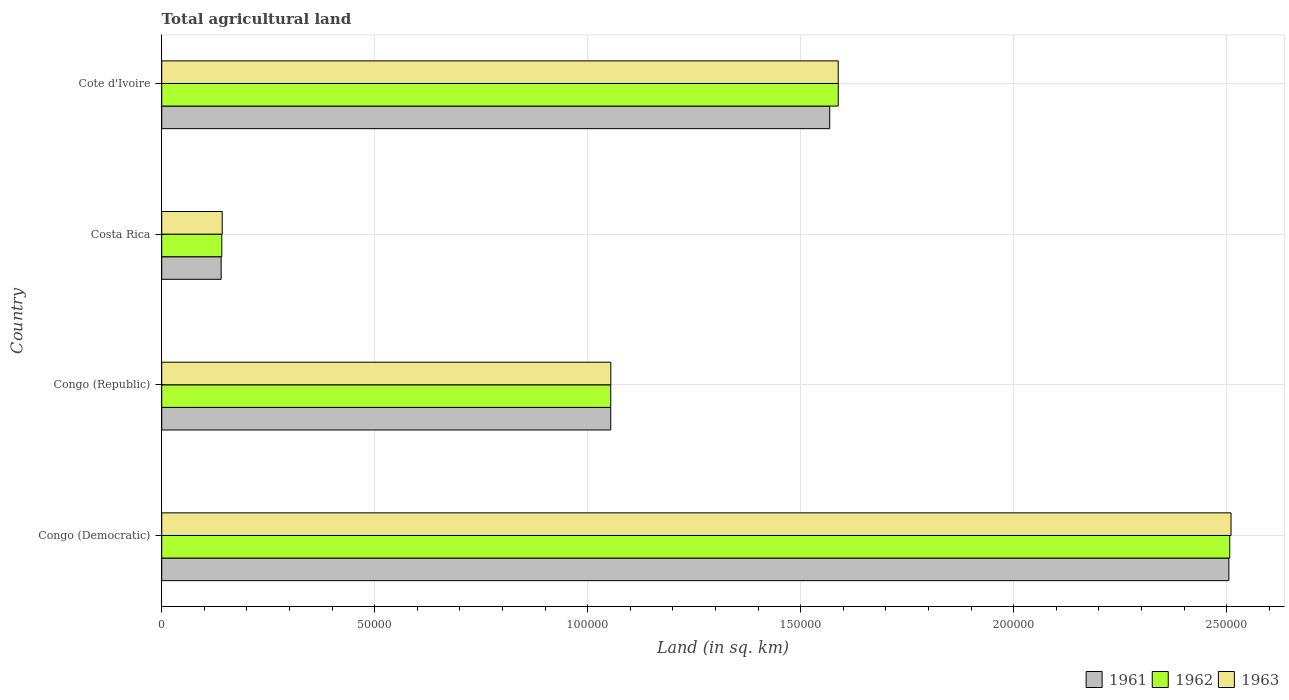How many different coloured bars are there?
Keep it short and to the point. 3. How many bars are there on the 4th tick from the bottom?
Make the answer very short. 3. What is the label of the 3rd group of bars from the top?
Give a very brief answer. Congo (Republic). What is the total agricultural land in 1961 in Cote d'Ivoire?
Provide a short and direct response. 1.57e+05. Across all countries, what is the maximum total agricultural land in 1963?
Keep it short and to the point. 2.51e+05. Across all countries, what is the minimum total agricultural land in 1963?
Keep it short and to the point. 1.42e+04. In which country was the total agricultural land in 1962 maximum?
Give a very brief answer. Congo (Democratic). What is the total total agricultural land in 1963 in the graph?
Provide a short and direct response. 5.29e+05. What is the difference between the total agricultural land in 1961 in Congo (Republic) and that in Costa Rica?
Make the answer very short. 9.14e+04. What is the difference between the total agricultural land in 1963 in Congo (Republic) and the total agricultural land in 1961 in Congo (Democratic)?
Make the answer very short. -1.45e+05. What is the average total agricultural land in 1963 per country?
Give a very brief answer. 1.32e+05. What is the difference between the total agricultural land in 1961 and total agricultural land in 1963 in Congo (Democratic)?
Give a very brief answer. -500. In how many countries, is the total agricultural land in 1962 greater than 10000 sq.km?
Offer a very short reply. 4. What is the ratio of the total agricultural land in 1962 in Congo (Democratic) to that in Cote d'Ivoire?
Offer a terse response. 1.58. Is the total agricultural land in 1961 in Costa Rica less than that in Cote d'Ivoire?
Make the answer very short. Yes. What is the difference between the highest and the second highest total agricultural land in 1961?
Provide a short and direct response. 9.37e+04. What is the difference between the highest and the lowest total agricultural land in 1961?
Give a very brief answer. 2.37e+05. In how many countries, is the total agricultural land in 1961 greater than the average total agricultural land in 1961 taken over all countries?
Keep it short and to the point. 2. What does the 1st bar from the bottom in Congo (Democratic) represents?
Ensure brevity in your answer.  1961. How many countries are there in the graph?
Your response must be concise. 4. What is the difference between two consecutive major ticks on the X-axis?
Keep it short and to the point. 5.00e+04. Are the values on the major ticks of X-axis written in scientific E-notation?
Your response must be concise. No. Does the graph contain any zero values?
Give a very brief answer. No. Does the graph contain grids?
Give a very brief answer. Yes. Where does the legend appear in the graph?
Provide a succinct answer. Bottom right. How many legend labels are there?
Provide a succinct answer. 3. What is the title of the graph?
Offer a very short reply. Total agricultural land. What is the label or title of the X-axis?
Your response must be concise. Land (in sq. km). What is the Land (in sq. km) of 1961 in Congo (Democratic)?
Ensure brevity in your answer.  2.50e+05. What is the Land (in sq. km) in 1962 in Congo (Democratic)?
Give a very brief answer. 2.51e+05. What is the Land (in sq. km) in 1963 in Congo (Democratic)?
Keep it short and to the point. 2.51e+05. What is the Land (in sq. km) in 1961 in Congo (Republic)?
Your answer should be compact. 1.05e+05. What is the Land (in sq. km) of 1962 in Congo (Republic)?
Ensure brevity in your answer.  1.05e+05. What is the Land (in sq. km) of 1963 in Congo (Republic)?
Give a very brief answer. 1.05e+05. What is the Land (in sq. km) of 1961 in Costa Rica?
Offer a very short reply. 1.40e+04. What is the Land (in sq. km) in 1962 in Costa Rica?
Make the answer very short. 1.41e+04. What is the Land (in sq. km) of 1963 in Costa Rica?
Offer a terse response. 1.42e+04. What is the Land (in sq. km) of 1961 in Cote d'Ivoire?
Offer a terse response. 1.57e+05. What is the Land (in sq. km) in 1962 in Cote d'Ivoire?
Ensure brevity in your answer.  1.59e+05. What is the Land (in sq. km) in 1963 in Cote d'Ivoire?
Make the answer very short. 1.59e+05. Across all countries, what is the maximum Land (in sq. km) in 1961?
Your answer should be very brief. 2.50e+05. Across all countries, what is the maximum Land (in sq. km) in 1962?
Provide a short and direct response. 2.51e+05. Across all countries, what is the maximum Land (in sq. km) of 1963?
Provide a short and direct response. 2.51e+05. Across all countries, what is the minimum Land (in sq. km) in 1961?
Give a very brief answer. 1.40e+04. Across all countries, what is the minimum Land (in sq. km) of 1962?
Your answer should be very brief. 1.41e+04. Across all countries, what is the minimum Land (in sq. km) in 1963?
Provide a short and direct response. 1.42e+04. What is the total Land (in sq. km) of 1961 in the graph?
Offer a very short reply. 5.27e+05. What is the total Land (in sq. km) of 1962 in the graph?
Make the answer very short. 5.29e+05. What is the total Land (in sq. km) in 1963 in the graph?
Your answer should be very brief. 5.29e+05. What is the difference between the Land (in sq. km) in 1961 in Congo (Democratic) and that in Congo (Republic)?
Keep it short and to the point. 1.45e+05. What is the difference between the Land (in sq. km) in 1962 in Congo (Democratic) and that in Congo (Republic)?
Your answer should be compact. 1.45e+05. What is the difference between the Land (in sq. km) in 1963 in Congo (Democratic) and that in Congo (Republic)?
Keep it short and to the point. 1.46e+05. What is the difference between the Land (in sq. km) in 1961 in Congo (Democratic) and that in Costa Rica?
Make the answer very short. 2.37e+05. What is the difference between the Land (in sq. km) in 1962 in Congo (Democratic) and that in Costa Rica?
Offer a terse response. 2.37e+05. What is the difference between the Land (in sq. km) in 1963 in Congo (Democratic) and that in Costa Rica?
Make the answer very short. 2.37e+05. What is the difference between the Land (in sq. km) of 1961 in Congo (Democratic) and that in Cote d'Ivoire?
Keep it short and to the point. 9.37e+04. What is the difference between the Land (in sq. km) in 1962 in Congo (Democratic) and that in Cote d'Ivoire?
Offer a terse response. 9.19e+04. What is the difference between the Land (in sq. km) in 1963 in Congo (Democratic) and that in Cote d'Ivoire?
Make the answer very short. 9.22e+04. What is the difference between the Land (in sq. km) of 1961 in Congo (Republic) and that in Costa Rica?
Your answer should be very brief. 9.14e+04. What is the difference between the Land (in sq. km) in 1962 in Congo (Republic) and that in Costa Rica?
Offer a terse response. 9.13e+04. What is the difference between the Land (in sq. km) in 1963 in Congo (Republic) and that in Costa Rica?
Ensure brevity in your answer.  9.12e+04. What is the difference between the Land (in sq. km) in 1961 in Congo (Republic) and that in Cote d'Ivoire?
Ensure brevity in your answer.  -5.14e+04. What is the difference between the Land (in sq. km) of 1962 in Congo (Republic) and that in Cote d'Ivoire?
Your answer should be very brief. -5.34e+04. What is the difference between the Land (in sq. km) in 1963 in Congo (Republic) and that in Cote d'Ivoire?
Provide a succinct answer. -5.34e+04. What is the difference between the Land (in sq. km) of 1961 in Costa Rica and that in Cote d'Ivoire?
Offer a very short reply. -1.43e+05. What is the difference between the Land (in sq. km) in 1962 in Costa Rica and that in Cote d'Ivoire?
Provide a succinct answer. -1.45e+05. What is the difference between the Land (in sq. km) of 1963 in Costa Rica and that in Cote d'Ivoire?
Keep it short and to the point. -1.45e+05. What is the difference between the Land (in sq. km) of 1961 in Congo (Democratic) and the Land (in sq. km) of 1962 in Congo (Republic)?
Keep it short and to the point. 1.45e+05. What is the difference between the Land (in sq. km) of 1961 in Congo (Democratic) and the Land (in sq. km) of 1963 in Congo (Republic)?
Your response must be concise. 1.45e+05. What is the difference between the Land (in sq. km) in 1962 in Congo (Democratic) and the Land (in sq. km) in 1963 in Congo (Republic)?
Make the answer very short. 1.45e+05. What is the difference between the Land (in sq. km) in 1961 in Congo (Democratic) and the Land (in sq. km) in 1962 in Costa Rica?
Keep it short and to the point. 2.36e+05. What is the difference between the Land (in sq. km) in 1961 in Congo (Democratic) and the Land (in sq. km) in 1963 in Costa Rica?
Make the answer very short. 2.36e+05. What is the difference between the Land (in sq. km) of 1962 in Congo (Democratic) and the Land (in sq. km) of 1963 in Costa Rica?
Your answer should be very brief. 2.36e+05. What is the difference between the Land (in sq. km) of 1961 in Congo (Democratic) and the Land (in sq. km) of 1962 in Cote d'Ivoire?
Provide a short and direct response. 9.17e+04. What is the difference between the Land (in sq. km) in 1961 in Congo (Democratic) and the Land (in sq. km) in 1963 in Cote d'Ivoire?
Give a very brief answer. 9.17e+04. What is the difference between the Land (in sq. km) of 1962 in Congo (Democratic) and the Land (in sq. km) of 1963 in Cote d'Ivoire?
Make the answer very short. 9.19e+04. What is the difference between the Land (in sq. km) of 1961 in Congo (Republic) and the Land (in sq. km) of 1962 in Costa Rica?
Keep it short and to the point. 9.13e+04. What is the difference between the Land (in sq. km) in 1961 in Congo (Republic) and the Land (in sq. km) in 1963 in Costa Rica?
Your response must be concise. 9.12e+04. What is the difference between the Land (in sq. km) of 1962 in Congo (Republic) and the Land (in sq. km) of 1963 in Costa Rica?
Keep it short and to the point. 9.12e+04. What is the difference between the Land (in sq. km) in 1961 in Congo (Republic) and the Land (in sq. km) in 1962 in Cote d'Ivoire?
Your answer should be compact. -5.34e+04. What is the difference between the Land (in sq. km) in 1961 in Congo (Republic) and the Land (in sq. km) in 1963 in Cote d'Ivoire?
Keep it short and to the point. -5.34e+04. What is the difference between the Land (in sq. km) of 1962 in Congo (Republic) and the Land (in sq. km) of 1963 in Cote d'Ivoire?
Provide a short and direct response. -5.34e+04. What is the difference between the Land (in sq. km) of 1961 in Costa Rica and the Land (in sq. km) of 1962 in Cote d'Ivoire?
Provide a short and direct response. -1.45e+05. What is the difference between the Land (in sq. km) of 1961 in Costa Rica and the Land (in sq. km) of 1963 in Cote d'Ivoire?
Provide a short and direct response. -1.45e+05. What is the difference between the Land (in sq. km) of 1962 in Costa Rica and the Land (in sq. km) of 1963 in Cote d'Ivoire?
Your response must be concise. -1.45e+05. What is the average Land (in sq. km) of 1961 per country?
Make the answer very short. 1.32e+05. What is the average Land (in sq. km) of 1962 per country?
Your answer should be very brief. 1.32e+05. What is the average Land (in sq. km) of 1963 per country?
Offer a terse response. 1.32e+05. What is the difference between the Land (in sq. km) in 1961 and Land (in sq. km) in 1962 in Congo (Democratic)?
Ensure brevity in your answer.  -200. What is the difference between the Land (in sq. km) of 1961 and Land (in sq. km) of 1963 in Congo (Democratic)?
Make the answer very short. -500. What is the difference between the Land (in sq. km) of 1962 and Land (in sq. km) of 1963 in Congo (Democratic)?
Make the answer very short. -300. What is the difference between the Land (in sq. km) of 1961 and Land (in sq. km) of 1962 in Congo (Republic)?
Give a very brief answer. 0. What is the difference between the Land (in sq. km) in 1961 and Land (in sq. km) in 1962 in Costa Rica?
Give a very brief answer. -150. What is the difference between the Land (in sq. km) in 1961 and Land (in sq. km) in 1963 in Costa Rica?
Your response must be concise. -250. What is the difference between the Land (in sq. km) of 1962 and Land (in sq. km) of 1963 in Costa Rica?
Give a very brief answer. -100. What is the difference between the Land (in sq. km) of 1961 and Land (in sq. km) of 1962 in Cote d'Ivoire?
Your answer should be compact. -2000. What is the difference between the Land (in sq. km) of 1961 and Land (in sq. km) of 1963 in Cote d'Ivoire?
Make the answer very short. -2000. What is the difference between the Land (in sq. km) of 1962 and Land (in sq. km) of 1963 in Cote d'Ivoire?
Ensure brevity in your answer.  0. What is the ratio of the Land (in sq. km) of 1961 in Congo (Democratic) to that in Congo (Republic)?
Your answer should be compact. 2.38. What is the ratio of the Land (in sq. km) of 1962 in Congo (Democratic) to that in Congo (Republic)?
Provide a short and direct response. 2.38. What is the ratio of the Land (in sq. km) of 1963 in Congo (Democratic) to that in Congo (Republic)?
Ensure brevity in your answer.  2.38. What is the ratio of the Land (in sq. km) of 1961 in Congo (Democratic) to that in Costa Rica?
Your response must be concise. 17.96. What is the ratio of the Land (in sq. km) of 1962 in Congo (Democratic) to that in Costa Rica?
Make the answer very short. 17.78. What is the ratio of the Land (in sq. km) in 1963 in Congo (Democratic) to that in Costa Rica?
Keep it short and to the point. 17.68. What is the ratio of the Land (in sq. km) in 1961 in Congo (Democratic) to that in Cote d'Ivoire?
Ensure brevity in your answer.  1.6. What is the ratio of the Land (in sq. km) of 1962 in Congo (Democratic) to that in Cote d'Ivoire?
Offer a very short reply. 1.58. What is the ratio of the Land (in sq. km) of 1963 in Congo (Democratic) to that in Cote d'Ivoire?
Provide a succinct answer. 1.58. What is the ratio of the Land (in sq. km) in 1961 in Congo (Republic) to that in Costa Rica?
Provide a succinct answer. 7.56. What is the ratio of the Land (in sq. km) in 1962 in Congo (Republic) to that in Costa Rica?
Give a very brief answer. 7.48. What is the ratio of the Land (in sq. km) in 1963 in Congo (Republic) to that in Costa Rica?
Give a very brief answer. 7.42. What is the ratio of the Land (in sq. km) of 1961 in Congo (Republic) to that in Cote d'Ivoire?
Offer a very short reply. 0.67. What is the ratio of the Land (in sq. km) of 1962 in Congo (Republic) to that in Cote d'Ivoire?
Provide a succinct answer. 0.66. What is the ratio of the Land (in sq. km) of 1963 in Congo (Republic) to that in Cote d'Ivoire?
Keep it short and to the point. 0.66. What is the ratio of the Land (in sq. km) of 1961 in Costa Rica to that in Cote d'Ivoire?
Your response must be concise. 0.09. What is the ratio of the Land (in sq. km) in 1962 in Costa Rica to that in Cote d'Ivoire?
Offer a very short reply. 0.09. What is the ratio of the Land (in sq. km) of 1963 in Costa Rica to that in Cote d'Ivoire?
Offer a very short reply. 0.09. What is the difference between the highest and the second highest Land (in sq. km) in 1961?
Provide a short and direct response. 9.37e+04. What is the difference between the highest and the second highest Land (in sq. km) in 1962?
Keep it short and to the point. 9.19e+04. What is the difference between the highest and the second highest Land (in sq. km) of 1963?
Make the answer very short. 9.22e+04. What is the difference between the highest and the lowest Land (in sq. km) in 1961?
Make the answer very short. 2.37e+05. What is the difference between the highest and the lowest Land (in sq. km) in 1962?
Your answer should be very brief. 2.37e+05. What is the difference between the highest and the lowest Land (in sq. km) in 1963?
Your response must be concise. 2.37e+05. 